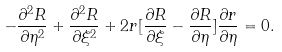<formula> <loc_0><loc_0><loc_500><loc_500>- \frac { \partial ^ { 2 } R } { \partial \eta ^ { 2 } } + \frac { \partial ^ { 2 } R } { \partial \xi ^ { 2 } } + 2 r [ \frac { \partial R } { \partial \xi } - \frac { \partial R } { \partial \eta } ] \frac { \partial r } { \partial \eta } = 0 .</formula> 